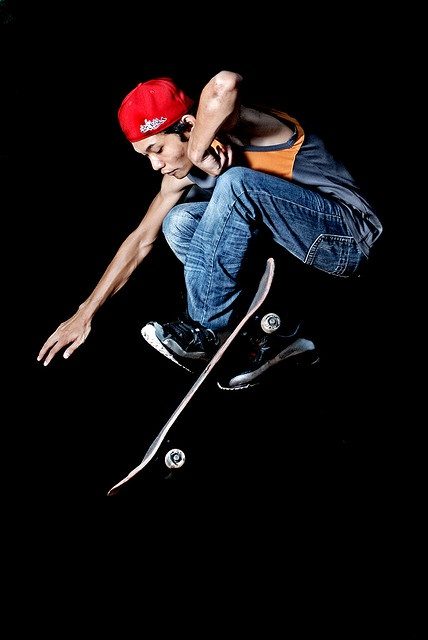Describe the objects in this image and their specific colors. I can see people in teal, black, tan, navy, and blue tones and skateboard in teal, black, lightgray, darkgray, and gray tones in this image. 